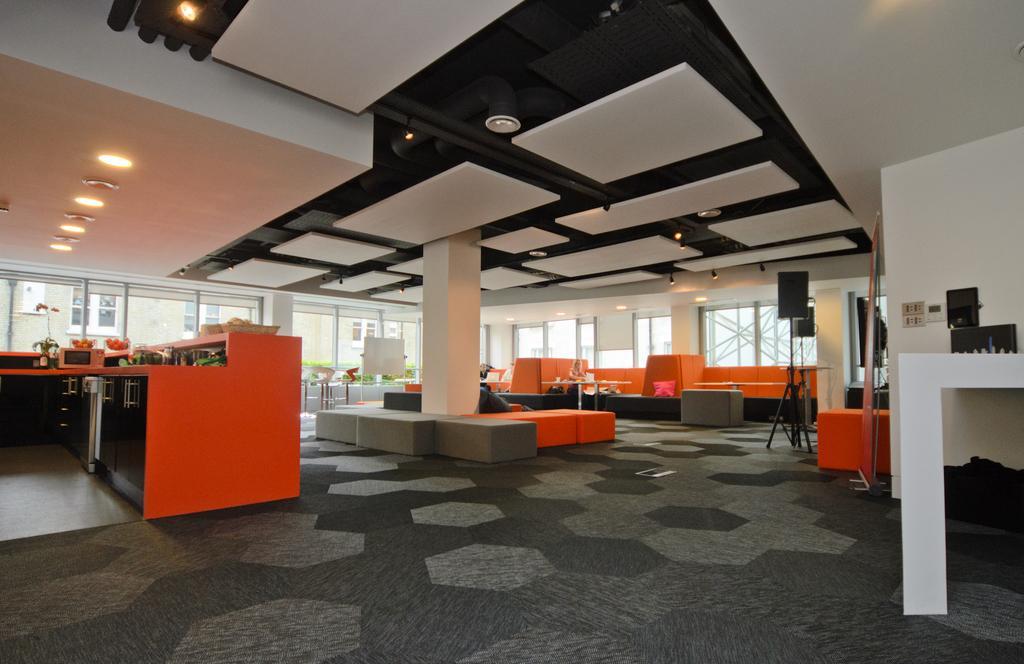Can you describe this image briefly? On the left side of the image there is a table. On top of it there is a microwave and a few other objects. At the bottom of the image there is a mat. On top of the image there are lights. In the background of the image there are glass windows. There is a board. There is a table. On the right side of the image there are speakers. There is a table. On top of it there are few objects. 